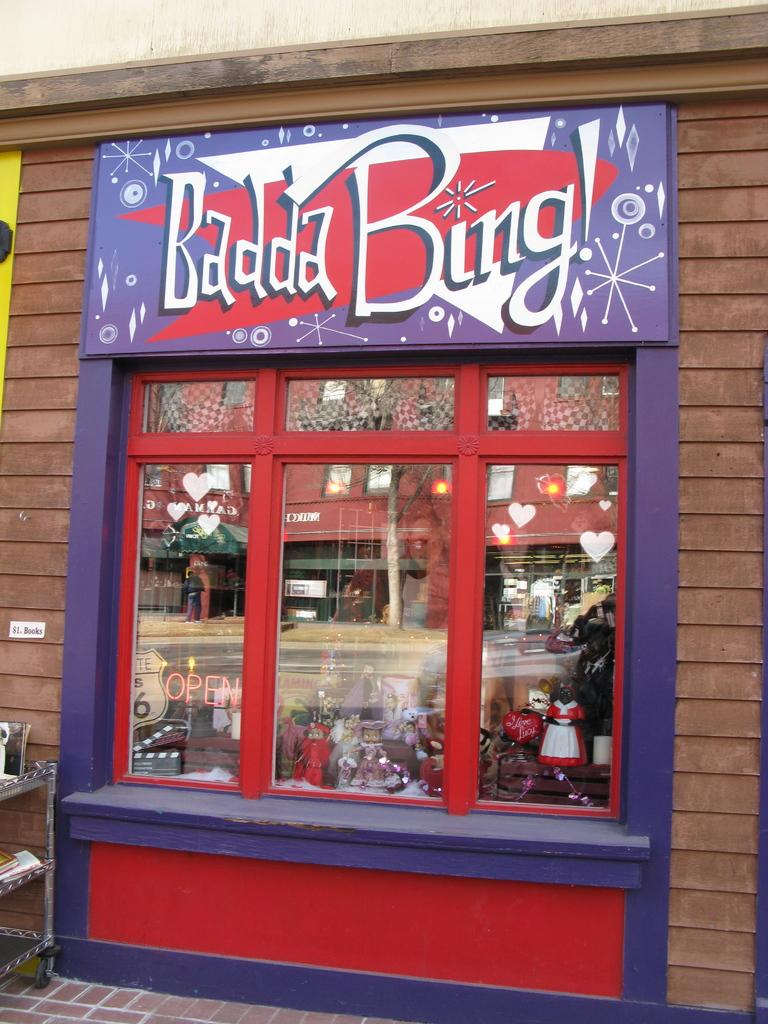What types of items can be seen on the shelves in the image? There are toys and other objects on the shelves in the image. How are the shelves protected or covered? The shelves are covered with glasses. What is attached to the building wall in the image? There is a hoarding attached to a building wall. Can you see any trails left by a fly in the image? There is no mention of a fly or any trails in the image, so we cannot answer this question. 